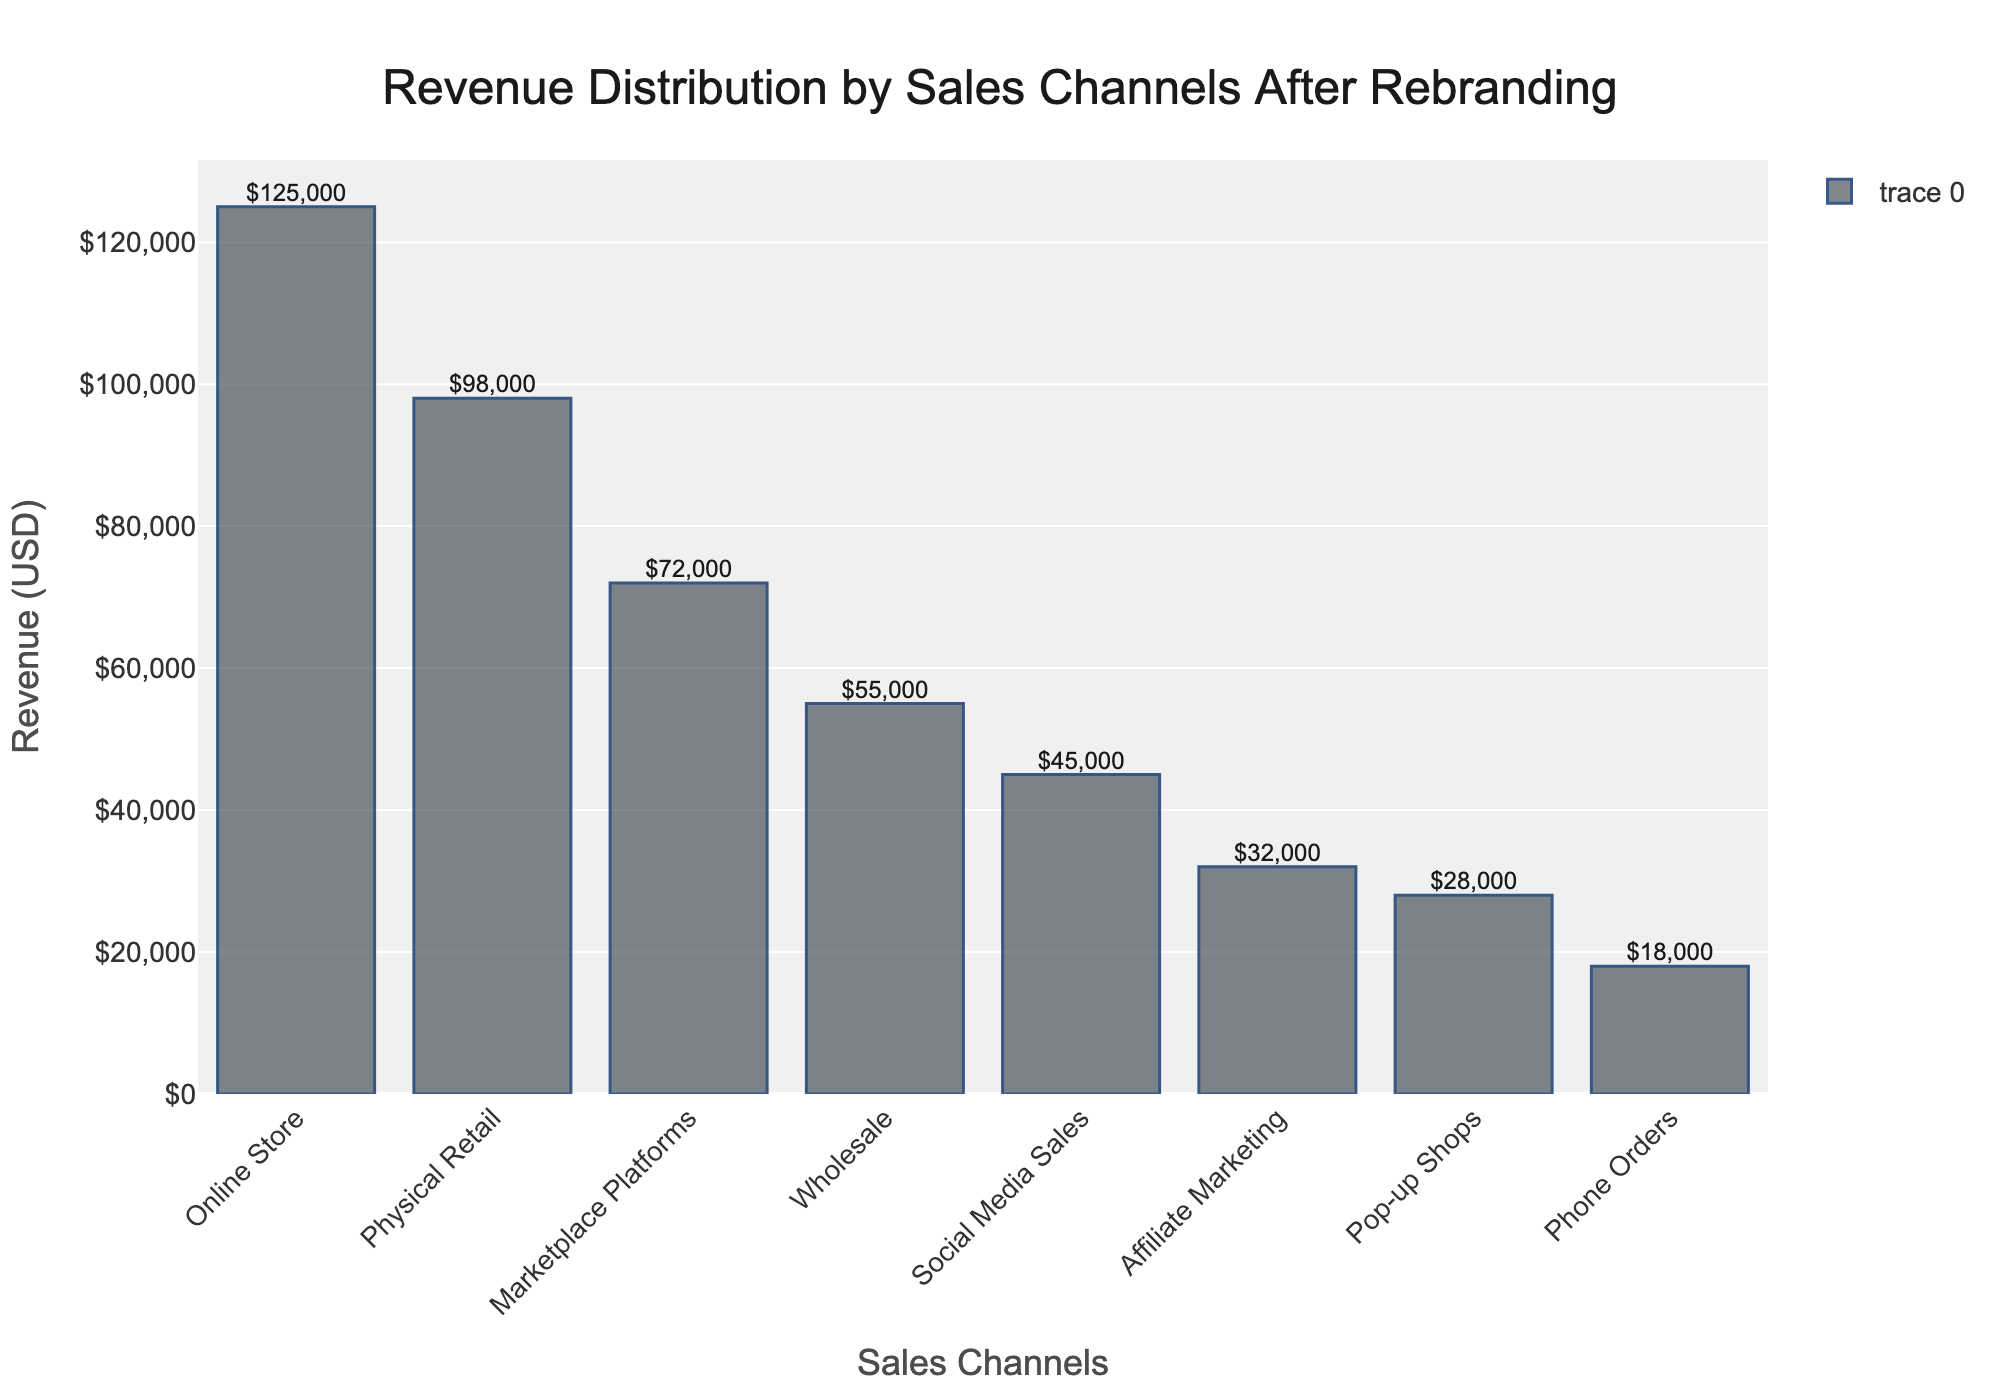Which sales channel has the highest revenue? The revenue values are displayed on top of each bar. The Online Store has the highest bar with a value of $125,000.
Answer: Online Store What is the total revenue generated by Pop-up Shops and Phone Orders combined? The figure shows Pop-up Shops generate $28,000 and Phone Orders generate $18,000. Adding these together: $28,000 + $18,000 = $46,000.
Answer: $46,000 Which sales channel has the lowest revenue? The revenue values are displayed on top of each bar. The lowest bar is for Phone Orders at $18,000.
Answer: Phone Orders How much more revenue does the Online Store generate compared to Physical Retail? The Online Store generates $125,000, and Physical Retail generates $98,000. The difference is $125,000 - $98,000 = $27,000.
Answer: $27,000 How does the revenue from Social Media Sales compare to Affiliate Marketing? The figure shows Social Media Sales generate $45,000, while Affiliate Marketing generates $32,000. Social Media Sales generate $13,000 more than Affiliate Marketing ($45,000 - $32,000).
Answer: $13,000 more What is the combined revenue of the top three sales channels? The top three sales channels are Online Store ($125,000), Physical Retail ($98,000), and Marketplace Platforms ($72,000). Adding these gives $125,000 + $98,000 + $72,000 = $295,000.
Answer: $295,000 Which sales channels generate more revenue than Marketplace Platforms? The revenue for Marketplace Platforms is $72,000. The channels with higher revenue are Online Store ($125,000) and Physical Retail ($98,000).
Answer: Online Store, Physical Retail What percentage of the total revenue is generated by Wholesale? First calculate the total revenue by summing all channels: $125,000 + $98,000 + $45,000 + $72,000 + $28,000 + $18,000 + $55,000 + $32,000 = $473,000. Wholesale revenue is $55,000. So the percentage is ($55,000 / $473,000) * 100 ≈ 11.63%.
Answer: ≈ 11.63% How much revenue in total is generated by channels other than the Online Store and Physical Retail? Total revenue: $473,000. Revenue from Online Store and Physical Retail: $125,000 + $98,000 = $223,000. Subtracting this: $473,000 - $223,000 = $250,000.
Answer: $250,000 What is the average revenue per sales channel? The total revenue is $473,000, and there are 8 sales channels. So, the average per channel is $473,000 / 8 = $59,125.
Answer: $59,125 